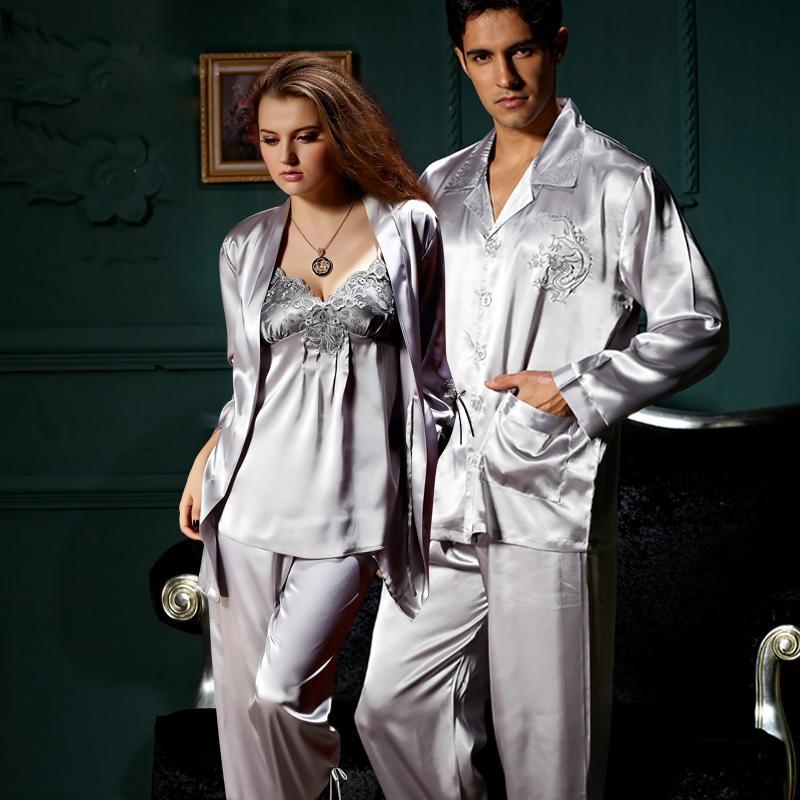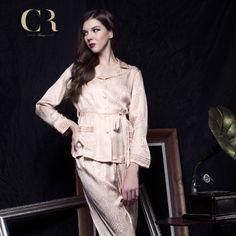The first image is the image on the left, the second image is the image on the right. Considering the images on both sides, is "The model on the left wears matching short-sleeve pajama top and capri-length bottoms, and the model on the right wears a robe over a spaghetti-strap gown." valid? Answer yes or no. No. The first image is the image on the left, the second image is the image on the right. Examine the images to the left and right. Is the description "Pajama pants in one image are knee length with lace edging, topped with a pajama shirt with tie belt at the waist." accurate? Answer yes or no. No. 